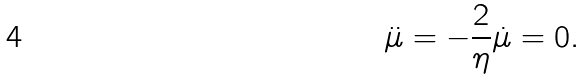<formula> <loc_0><loc_0><loc_500><loc_500>\ddot { \mu } = - \frac { 2 } { \eta } \dot { \mu } = 0 .</formula> 